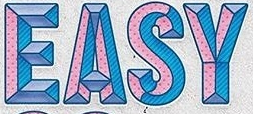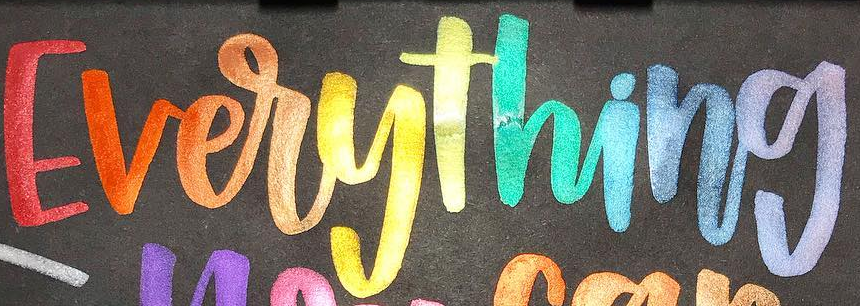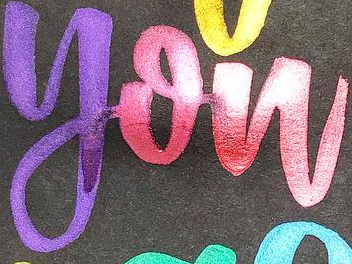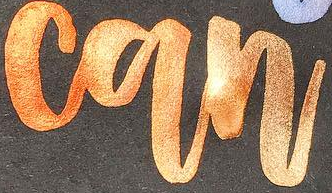What words are shown in these images in order, separated by a semicolon? EASY; Everything; you; can 